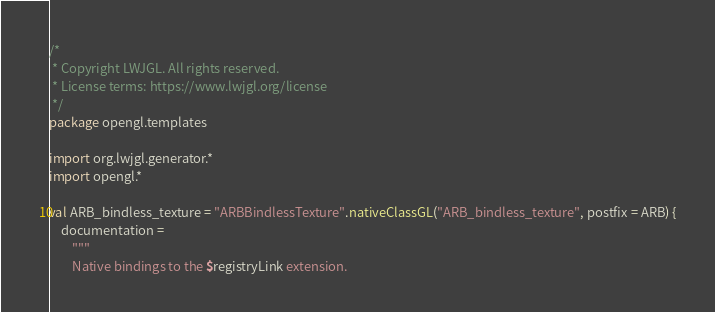<code> <loc_0><loc_0><loc_500><loc_500><_Kotlin_>/*
 * Copyright LWJGL. All rights reserved.
 * License terms: https://www.lwjgl.org/license
 */
package opengl.templates

import org.lwjgl.generator.*
import opengl.*

val ARB_bindless_texture = "ARBBindlessTexture".nativeClassGL("ARB_bindless_texture", postfix = ARB) {
    documentation =
        """
        Native bindings to the $registryLink extension.
</code> 